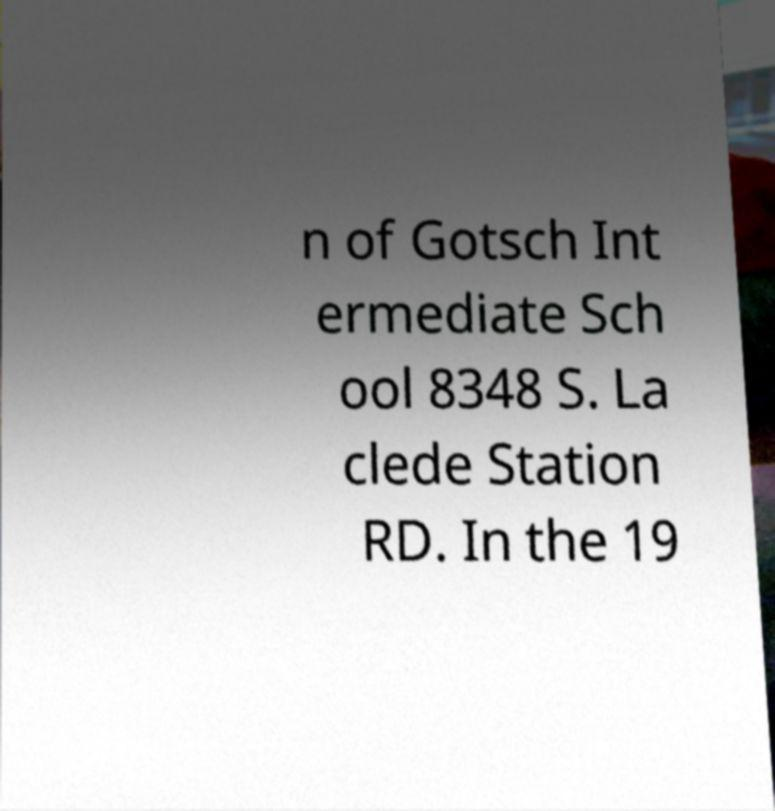I need the written content from this picture converted into text. Can you do that? n of Gotsch Int ermediate Sch ool 8348 S. La clede Station RD. In the 19 